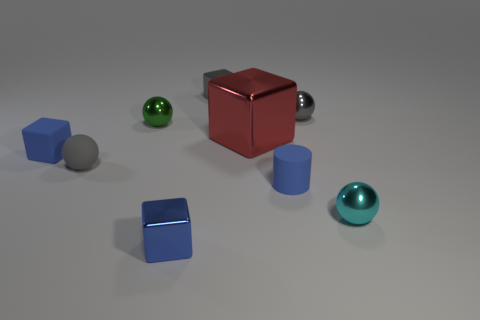There is a red shiny object; is it the same size as the blue object that is to the left of the blue metal object?
Make the answer very short. No. Are there any gray things of the same size as the blue rubber block?
Provide a short and direct response. Yes. How many other objects are there of the same material as the big red cube?
Your response must be concise. 5. There is a shiny block that is in front of the gray metallic block and behind the tiny cyan thing; what color is it?
Ensure brevity in your answer.  Red. Are the cube that is in front of the tiny matte cylinder and the tiny blue block left of the blue metallic cube made of the same material?
Your answer should be very brief. No. There is a shiny sphere behind the green object; does it have the same size as the small cyan metallic object?
Give a very brief answer. Yes. Do the cylinder and the tiny metallic cube in front of the tiny matte cube have the same color?
Provide a succinct answer. Yes. What shape is the small metallic thing that is the same color as the cylinder?
Provide a succinct answer. Cube. What is the shape of the big red thing?
Keep it short and to the point. Cube. Is the matte cylinder the same color as the small matte block?
Provide a short and direct response. Yes. 